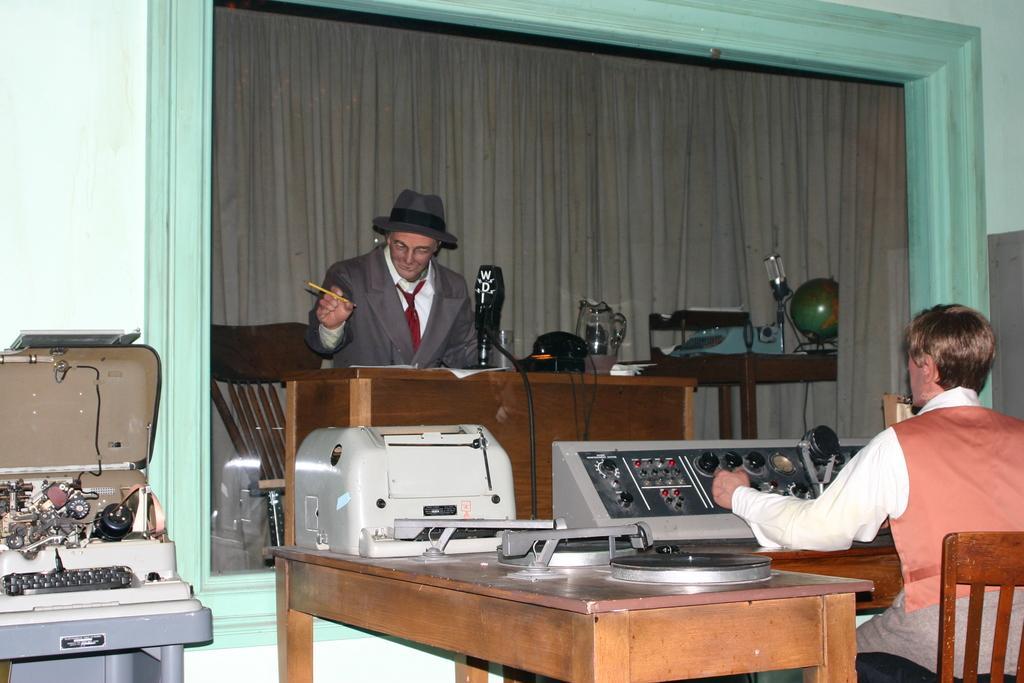In one or two sentences, can you explain what this image depicts? There are people sitting on the chairs. One person is operating an electronic device and the other person is holding the pen. This is the table with paper,glass jar and some other objects. This is the globe and lamp placed on the table. This is another electronic device. These look like toys that is which are not like real human. 